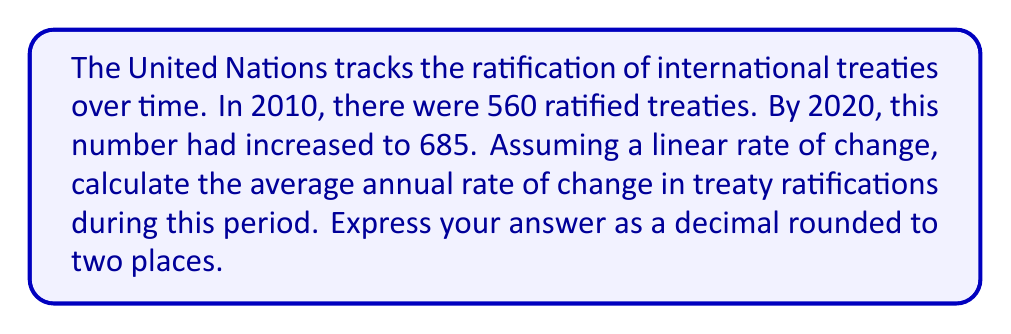Help me with this question. To solve this problem, we'll use the concept of average rate of change. The formula for average rate of change is:

$$ \text{Average rate of change} = \frac{\text{Change in y}}{\text{Change in x}} $$

Where y represents the dependent variable (number of ratified treaties) and x represents the independent variable (time in years).

Given:
- Initial year (x₁) = 2010
- Final year (x₂) = 2020
- Initial number of treaties (y₁) = 560
- Final number of treaties (y₂) = 685

Step 1: Calculate the change in y (Δy)
$$ \Delta y = y_2 - y_1 = 685 - 560 = 125 $$

Step 2: Calculate the change in x (Δx)
$$ \Delta x = x_2 - x_1 = 2020 - 2010 = 10 \text{ years} $$

Step 3: Apply the average rate of change formula
$$ \text{Average rate of change} = \frac{\Delta y}{\Delta x} = \frac{125}{10} = 12.5 $$

Therefore, the average annual rate of change in treaty ratifications is 12.5 treaties per year.

Step 4: Round to two decimal places
12.5 is already expressed to two decimal places, so no further rounding is necessary.
Answer: 12.50 